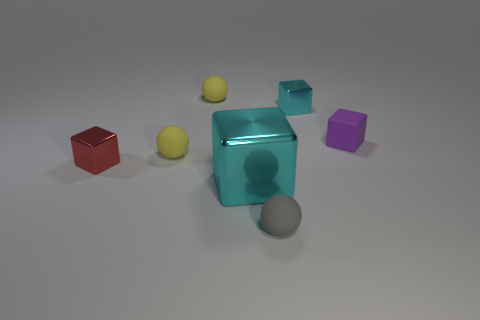The other cyan thing that is the same material as the large object is what shape?
Your response must be concise. Cube. What number of metal things are tiny purple blocks or large blocks?
Ensure brevity in your answer.  1. How many cyan things are behind the small block on the right side of the cyan thing that is behind the small red block?
Provide a short and direct response. 1. There is a cube that is behind the purple rubber thing; is it the same size as the cyan cube in front of the small purple rubber block?
Offer a terse response. No. There is a tiny purple thing that is the same shape as the tiny red metal object; what material is it?
Offer a terse response. Rubber. How many large things are red shiny blocks or gray metallic cylinders?
Keep it short and to the point. 0. What is the material of the large object?
Make the answer very short. Metal. The object that is both left of the small cyan metal cube and on the right side of the big cyan shiny object is made of what material?
Offer a terse response. Rubber. There is a large block; is it the same color as the tiny block that is left of the tiny gray matte ball?
Give a very brief answer. No. There is a gray thing that is the same size as the rubber cube; what is its material?
Make the answer very short. Rubber. 